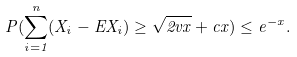<formula> <loc_0><loc_0><loc_500><loc_500>P ( \sum _ { i = 1 } ^ { n } ( X _ { i } - E X _ { i } ) \geq \sqrt { 2 v x } + c x ) \leq e ^ { - x } .</formula> 